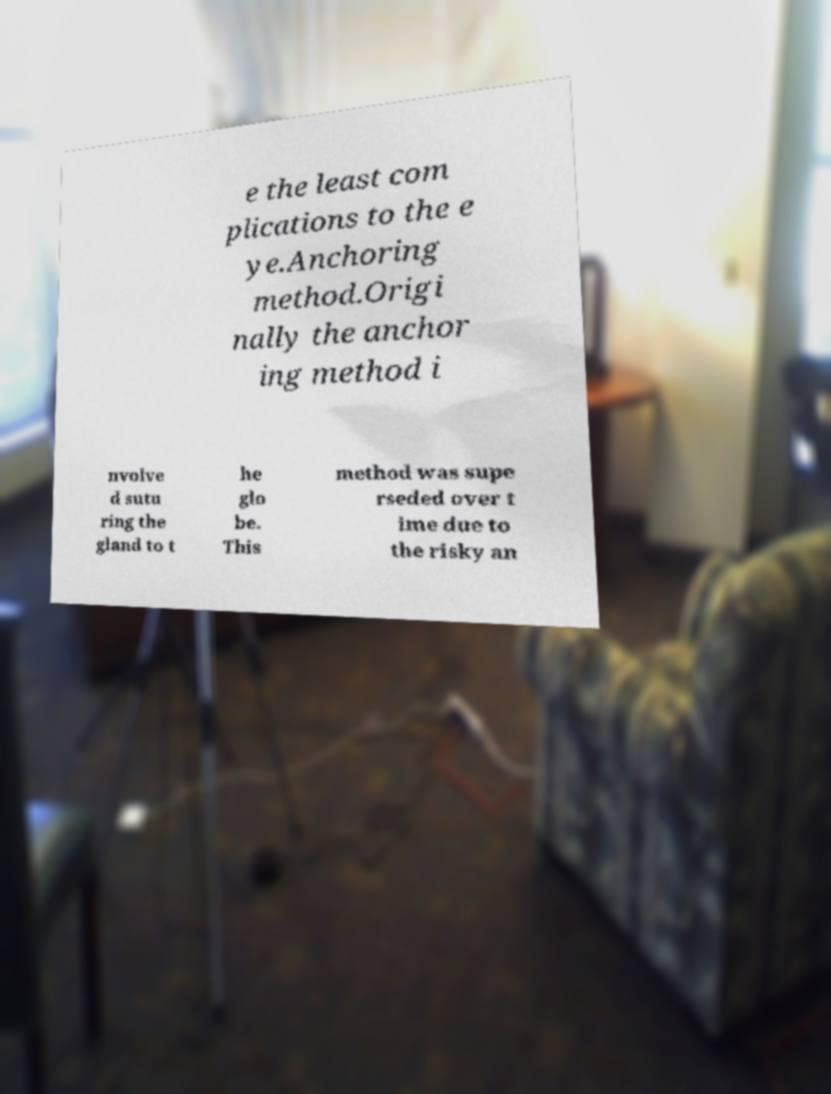Could you extract and type out the text from this image? e the least com plications to the e ye.Anchoring method.Origi nally the anchor ing method i nvolve d sutu ring the gland to t he glo be. This method was supe rseded over t ime due to the risky an 